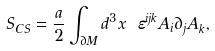<formula> <loc_0><loc_0><loc_500><loc_500>S _ { C S } = \frac { a } { 2 } \int _ { \partial M } d ^ { 3 } x \ \varepsilon ^ { i j k } A _ { i } \partial _ { j } A _ { k } ,</formula> 